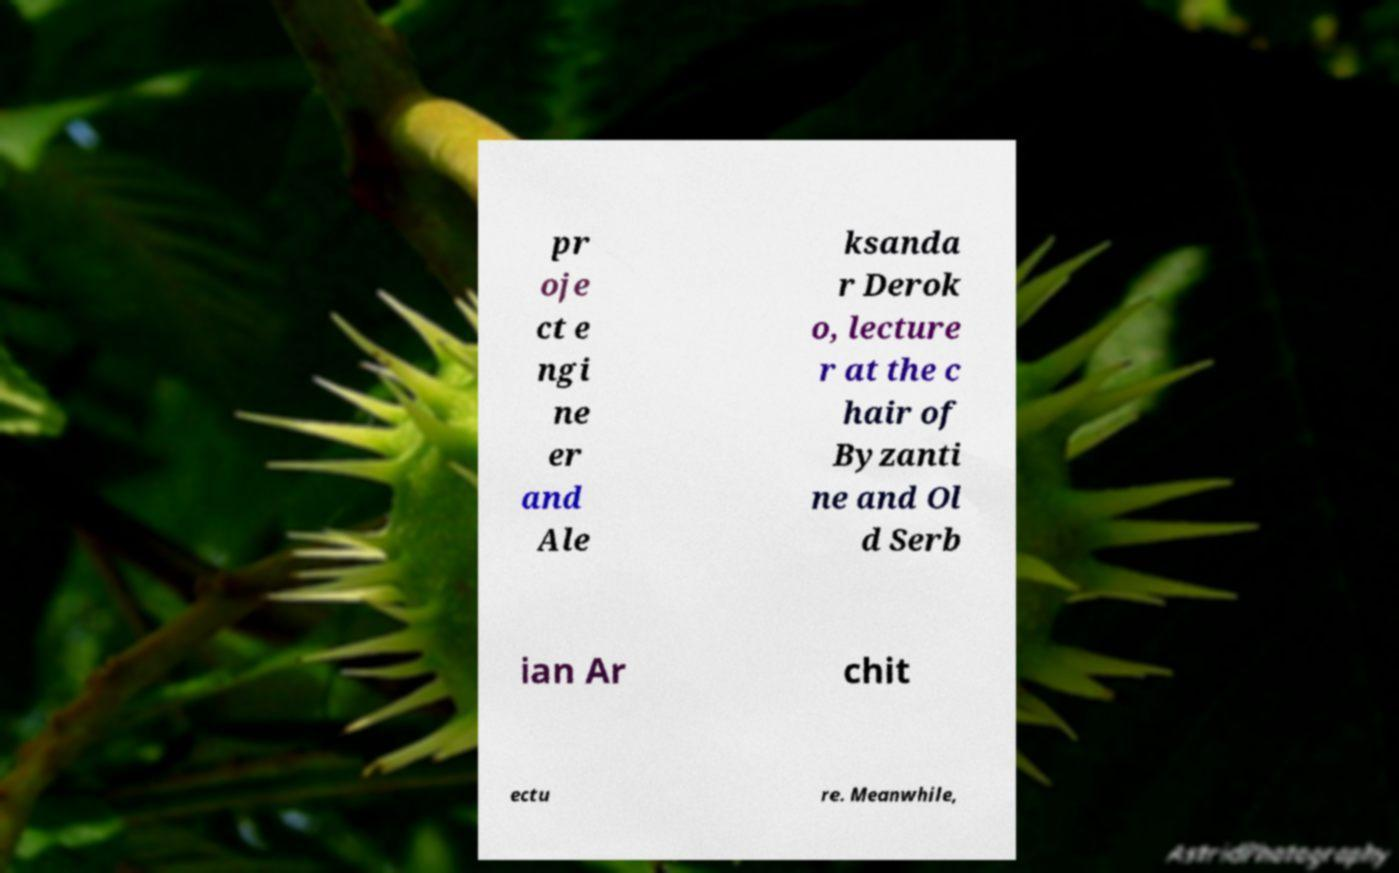Can you read and provide the text displayed in the image?This photo seems to have some interesting text. Can you extract and type it out for me? pr oje ct e ngi ne er and Ale ksanda r Derok o, lecture r at the c hair of Byzanti ne and Ol d Serb ian Ar chit ectu re. Meanwhile, 